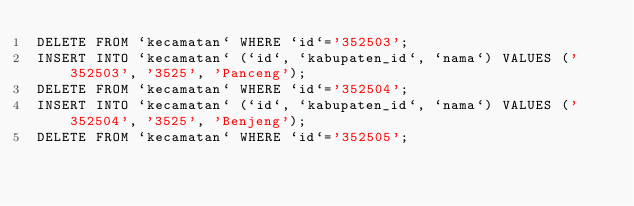<code> <loc_0><loc_0><loc_500><loc_500><_SQL_>DELETE FROM `kecamatan` WHERE `id`='352503';
INSERT INTO `kecamatan` (`id`, `kabupaten_id`, `nama`) VALUES ('352503', '3525', 'Panceng');
DELETE FROM `kecamatan` WHERE `id`='352504';
INSERT INTO `kecamatan` (`id`, `kabupaten_id`, `nama`) VALUES ('352504', '3525', 'Benjeng');
DELETE FROM `kecamatan` WHERE `id`='352505';</code> 